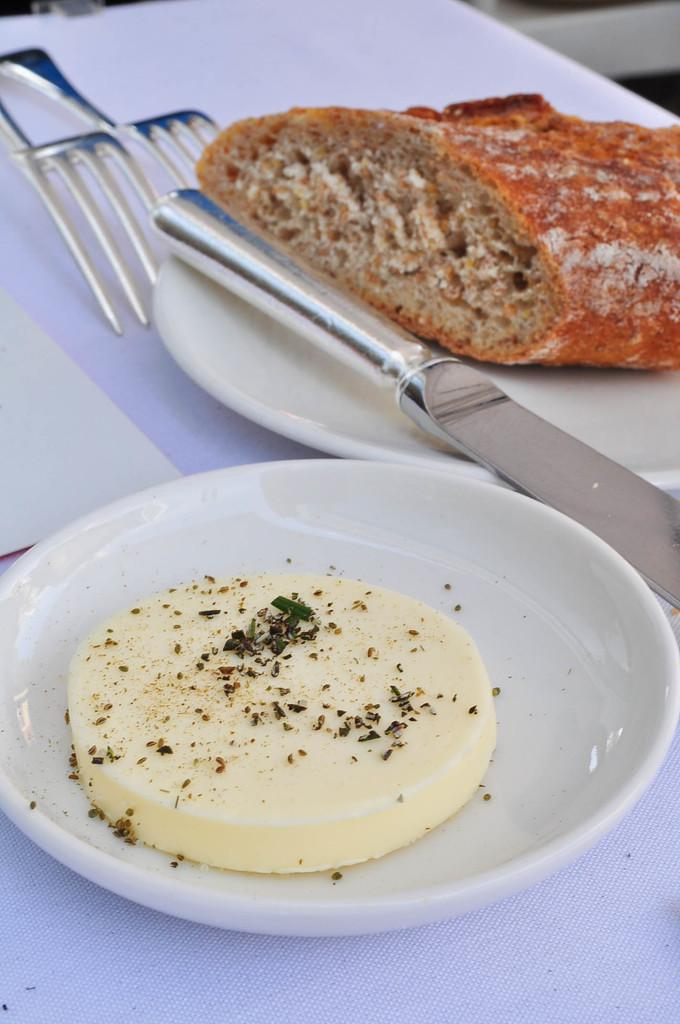What type of objects can be seen in the image? There are food items, a knife on a white color plate, and forks visible in the image. Where are these objects located? These objects are on a table in the image. Can you describe the knife in the image? The knife is on a white color plate in the image. What other objects might be present on the table? There are other objects on the table, but their specific details are not mentioned in the provided facts. How does the range of emotions displayed by the cough in the image affect the afterthought of the food items? There is no cough or range of emotions present in the image, and therefore no such effect can be observed. 